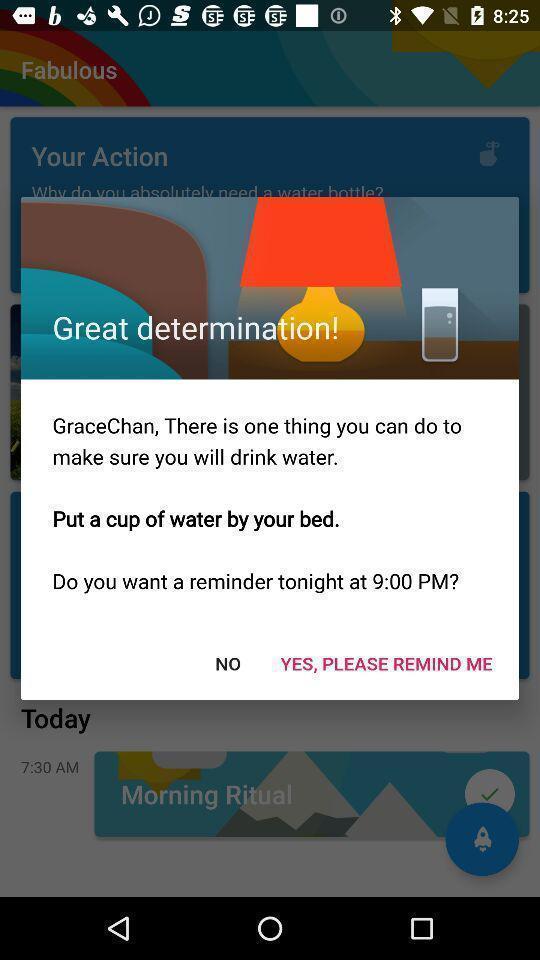Describe the visual elements of this screenshot. Pop-up displaying a remainder message. 